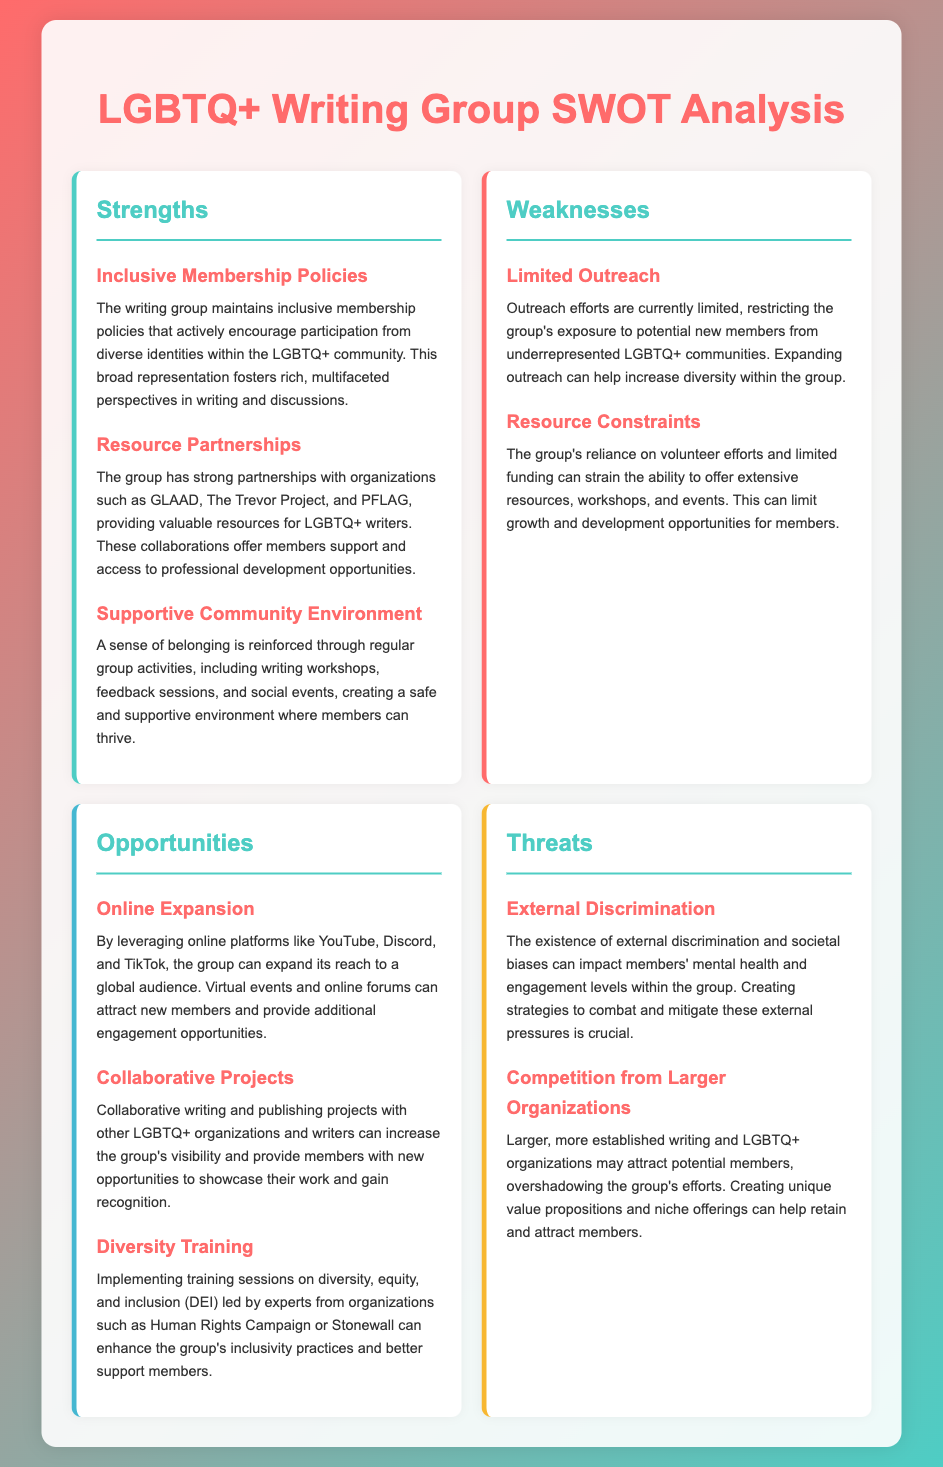what are the strengths of the writing group? The strengths of the writing group include inclusive membership policies, resource partnerships, and a supportive community environment.
Answer: Inclusive membership policies, resource partnerships, supportive community environment what is one weakness of the writing group? The weaknesses highlighted include limited outreach and resource constraints.
Answer: Limited outreach how many organizations are mentioned as partners? The document states that the group has strong partnerships with three specific organizations providing resources.
Answer: Three which external threat affects members' mental health? The existence of external discrimination and societal biases is mentioned as an external threat.
Answer: External discrimination what opportunity could help the group expand its reach? Leveraging online platforms like YouTube, Discord, and TikTok is presented as an opportunity for expansion.
Answer: Online platforms what type of training can enhance inclusivity practices? The document suggests implementing training sessions on diversity, equity, and inclusion (DEI).
Answer: Diversity training what are the opportunities mentioned for the writing group? The document outlines opportunities such as online expansion, collaborative projects, and diversity training.
Answer: Online expansion, collaborative projects, diversity training what is a major resource constraint impacting the group? The group's reliance on volunteer efforts and limited funding can strain the ability to offer extensive resources.
Answer: Limited funding how does the group foster a sense of belonging? The group creates a sense of belonging through regular activities such as writing workshops, feedback sessions, and social events.
Answer: Regular activities 